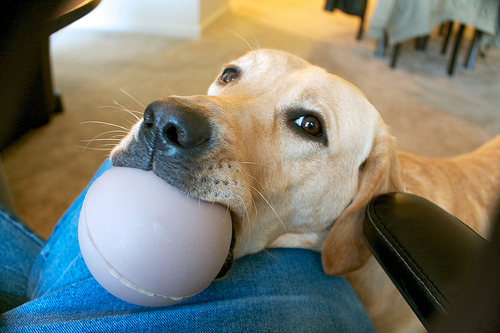<image>
Can you confirm if the ball is next to the dog? No. The ball is not positioned next to the dog. They are located in different areas of the scene. Is there a ball in the dog? Yes. The ball is contained within or inside the dog, showing a containment relationship. 